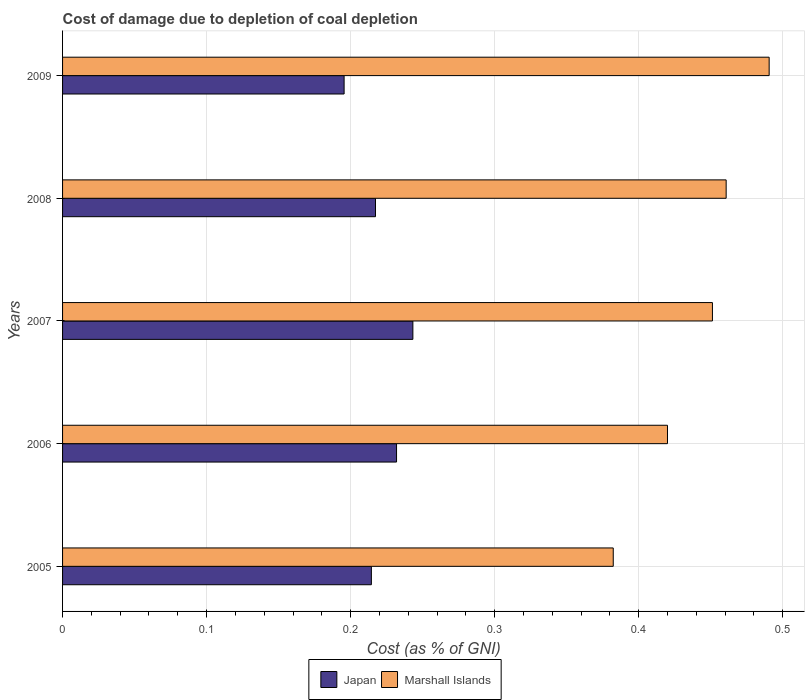How many different coloured bars are there?
Your response must be concise. 2. How many bars are there on the 2nd tick from the top?
Ensure brevity in your answer.  2. What is the label of the 2nd group of bars from the top?
Make the answer very short. 2008. In how many cases, is the number of bars for a given year not equal to the number of legend labels?
Keep it short and to the point. 0. What is the cost of damage caused due to coal depletion in Japan in 2009?
Your answer should be very brief. 0.2. Across all years, what is the maximum cost of damage caused due to coal depletion in Marshall Islands?
Ensure brevity in your answer.  0.49. Across all years, what is the minimum cost of damage caused due to coal depletion in Marshall Islands?
Give a very brief answer. 0.38. What is the total cost of damage caused due to coal depletion in Marshall Islands in the graph?
Offer a very short reply. 2.2. What is the difference between the cost of damage caused due to coal depletion in Marshall Islands in 2006 and that in 2009?
Provide a succinct answer. -0.07. What is the difference between the cost of damage caused due to coal depletion in Japan in 2009 and the cost of damage caused due to coal depletion in Marshall Islands in 2007?
Provide a short and direct response. -0.26. What is the average cost of damage caused due to coal depletion in Marshall Islands per year?
Offer a very short reply. 0.44. In the year 2005, what is the difference between the cost of damage caused due to coal depletion in Marshall Islands and cost of damage caused due to coal depletion in Japan?
Your answer should be compact. 0.17. In how many years, is the cost of damage caused due to coal depletion in Japan greater than 0.28 %?
Your response must be concise. 0. What is the ratio of the cost of damage caused due to coal depletion in Marshall Islands in 2005 to that in 2007?
Offer a very short reply. 0.85. Is the difference between the cost of damage caused due to coal depletion in Marshall Islands in 2006 and 2009 greater than the difference between the cost of damage caused due to coal depletion in Japan in 2006 and 2009?
Provide a succinct answer. No. What is the difference between the highest and the second highest cost of damage caused due to coal depletion in Japan?
Provide a succinct answer. 0.01. What is the difference between the highest and the lowest cost of damage caused due to coal depletion in Marshall Islands?
Keep it short and to the point. 0.11. In how many years, is the cost of damage caused due to coal depletion in Marshall Islands greater than the average cost of damage caused due to coal depletion in Marshall Islands taken over all years?
Offer a very short reply. 3. Is the sum of the cost of damage caused due to coal depletion in Marshall Islands in 2005 and 2007 greater than the maximum cost of damage caused due to coal depletion in Japan across all years?
Your answer should be very brief. Yes. What does the 1st bar from the top in 2007 represents?
Provide a short and direct response. Marshall Islands. How many bars are there?
Offer a very short reply. 10. Are all the bars in the graph horizontal?
Give a very brief answer. Yes. How many years are there in the graph?
Give a very brief answer. 5. Are the values on the major ticks of X-axis written in scientific E-notation?
Your response must be concise. No. Does the graph contain grids?
Give a very brief answer. Yes. Where does the legend appear in the graph?
Provide a succinct answer. Bottom center. What is the title of the graph?
Your answer should be very brief. Cost of damage due to depletion of coal depletion. What is the label or title of the X-axis?
Provide a short and direct response. Cost (as % of GNI). What is the label or title of the Y-axis?
Your response must be concise. Years. What is the Cost (as % of GNI) in Japan in 2005?
Keep it short and to the point. 0.21. What is the Cost (as % of GNI) in Marshall Islands in 2005?
Offer a very short reply. 0.38. What is the Cost (as % of GNI) in Japan in 2006?
Your answer should be very brief. 0.23. What is the Cost (as % of GNI) of Marshall Islands in 2006?
Your response must be concise. 0.42. What is the Cost (as % of GNI) of Japan in 2007?
Keep it short and to the point. 0.24. What is the Cost (as % of GNI) of Marshall Islands in 2007?
Provide a succinct answer. 0.45. What is the Cost (as % of GNI) in Japan in 2008?
Offer a very short reply. 0.22. What is the Cost (as % of GNI) of Marshall Islands in 2008?
Provide a succinct answer. 0.46. What is the Cost (as % of GNI) of Japan in 2009?
Offer a very short reply. 0.2. What is the Cost (as % of GNI) of Marshall Islands in 2009?
Provide a succinct answer. 0.49. Across all years, what is the maximum Cost (as % of GNI) in Japan?
Provide a short and direct response. 0.24. Across all years, what is the maximum Cost (as % of GNI) in Marshall Islands?
Your answer should be very brief. 0.49. Across all years, what is the minimum Cost (as % of GNI) in Japan?
Offer a very short reply. 0.2. Across all years, what is the minimum Cost (as % of GNI) in Marshall Islands?
Provide a succinct answer. 0.38. What is the total Cost (as % of GNI) of Japan in the graph?
Ensure brevity in your answer.  1.1. What is the total Cost (as % of GNI) of Marshall Islands in the graph?
Provide a succinct answer. 2.21. What is the difference between the Cost (as % of GNI) in Japan in 2005 and that in 2006?
Make the answer very short. -0.02. What is the difference between the Cost (as % of GNI) of Marshall Islands in 2005 and that in 2006?
Ensure brevity in your answer.  -0.04. What is the difference between the Cost (as % of GNI) of Japan in 2005 and that in 2007?
Ensure brevity in your answer.  -0.03. What is the difference between the Cost (as % of GNI) of Marshall Islands in 2005 and that in 2007?
Make the answer very short. -0.07. What is the difference between the Cost (as % of GNI) in Japan in 2005 and that in 2008?
Provide a succinct answer. -0. What is the difference between the Cost (as % of GNI) in Marshall Islands in 2005 and that in 2008?
Offer a very short reply. -0.08. What is the difference between the Cost (as % of GNI) in Japan in 2005 and that in 2009?
Provide a short and direct response. 0.02. What is the difference between the Cost (as % of GNI) of Marshall Islands in 2005 and that in 2009?
Your response must be concise. -0.11. What is the difference between the Cost (as % of GNI) of Japan in 2006 and that in 2007?
Offer a very short reply. -0.01. What is the difference between the Cost (as % of GNI) of Marshall Islands in 2006 and that in 2007?
Ensure brevity in your answer.  -0.03. What is the difference between the Cost (as % of GNI) of Japan in 2006 and that in 2008?
Keep it short and to the point. 0.01. What is the difference between the Cost (as % of GNI) in Marshall Islands in 2006 and that in 2008?
Give a very brief answer. -0.04. What is the difference between the Cost (as % of GNI) in Japan in 2006 and that in 2009?
Offer a very short reply. 0.04. What is the difference between the Cost (as % of GNI) of Marshall Islands in 2006 and that in 2009?
Ensure brevity in your answer.  -0.07. What is the difference between the Cost (as % of GNI) in Japan in 2007 and that in 2008?
Ensure brevity in your answer.  0.03. What is the difference between the Cost (as % of GNI) of Marshall Islands in 2007 and that in 2008?
Ensure brevity in your answer.  -0.01. What is the difference between the Cost (as % of GNI) in Japan in 2007 and that in 2009?
Offer a very short reply. 0.05. What is the difference between the Cost (as % of GNI) in Marshall Islands in 2007 and that in 2009?
Your answer should be compact. -0.04. What is the difference between the Cost (as % of GNI) of Japan in 2008 and that in 2009?
Give a very brief answer. 0.02. What is the difference between the Cost (as % of GNI) in Marshall Islands in 2008 and that in 2009?
Provide a short and direct response. -0.03. What is the difference between the Cost (as % of GNI) of Japan in 2005 and the Cost (as % of GNI) of Marshall Islands in 2006?
Your answer should be very brief. -0.21. What is the difference between the Cost (as % of GNI) of Japan in 2005 and the Cost (as % of GNI) of Marshall Islands in 2007?
Your response must be concise. -0.24. What is the difference between the Cost (as % of GNI) of Japan in 2005 and the Cost (as % of GNI) of Marshall Islands in 2008?
Your answer should be very brief. -0.25. What is the difference between the Cost (as % of GNI) of Japan in 2005 and the Cost (as % of GNI) of Marshall Islands in 2009?
Give a very brief answer. -0.28. What is the difference between the Cost (as % of GNI) in Japan in 2006 and the Cost (as % of GNI) in Marshall Islands in 2007?
Provide a succinct answer. -0.22. What is the difference between the Cost (as % of GNI) in Japan in 2006 and the Cost (as % of GNI) in Marshall Islands in 2008?
Offer a terse response. -0.23. What is the difference between the Cost (as % of GNI) of Japan in 2006 and the Cost (as % of GNI) of Marshall Islands in 2009?
Provide a short and direct response. -0.26. What is the difference between the Cost (as % of GNI) in Japan in 2007 and the Cost (as % of GNI) in Marshall Islands in 2008?
Offer a terse response. -0.22. What is the difference between the Cost (as % of GNI) of Japan in 2007 and the Cost (as % of GNI) of Marshall Islands in 2009?
Keep it short and to the point. -0.25. What is the difference between the Cost (as % of GNI) of Japan in 2008 and the Cost (as % of GNI) of Marshall Islands in 2009?
Offer a very short reply. -0.27. What is the average Cost (as % of GNI) of Japan per year?
Provide a succinct answer. 0.22. What is the average Cost (as % of GNI) of Marshall Islands per year?
Your answer should be very brief. 0.44. In the year 2005, what is the difference between the Cost (as % of GNI) in Japan and Cost (as % of GNI) in Marshall Islands?
Offer a terse response. -0.17. In the year 2006, what is the difference between the Cost (as % of GNI) of Japan and Cost (as % of GNI) of Marshall Islands?
Make the answer very short. -0.19. In the year 2007, what is the difference between the Cost (as % of GNI) in Japan and Cost (as % of GNI) in Marshall Islands?
Keep it short and to the point. -0.21. In the year 2008, what is the difference between the Cost (as % of GNI) in Japan and Cost (as % of GNI) in Marshall Islands?
Provide a short and direct response. -0.24. In the year 2009, what is the difference between the Cost (as % of GNI) in Japan and Cost (as % of GNI) in Marshall Islands?
Keep it short and to the point. -0.3. What is the ratio of the Cost (as % of GNI) of Japan in 2005 to that in 2006?
Your response must be concise. 0.92. What is the ratio of the Cost (as % of GNI) of Marshall Islands in 2005 to that in 2006?
Provide a succinct answer. 0.91. What is the ratio of the Cost (as % of GNI) of Japan in 2005 to that in 2007?
Offer a very short reply. 0.88. What is the ratio of the Cost (as % of GNI) of Marshall Islands in 2005 to that in 2007?
Provide a short and direct response. 0.85. What is the ratio of the Cost (as % of GNI) in Marshall Islands in 2005 to that in 2008?
Make the answer very short. 0.83. What is the ratio of the Cost (as % of GNI) of Japan in 2005 to that in 2009?
Make the answer very short. 1.1. What is the ratio of the Cost (as % of GNI) in Marshall Islands in 2005 to that in 2009?
Offer a terse response. 0.78. What is the ratio of the Cost (as % of GNI) in Japan in 2006 to that in 2007?
Your answer should be very brief. 0.95. What is the ratio of the Cost (as % of GNI) in Marshall Islands in 2006 to that in 2007?
Provide a short and direct response. 0.93. What is the ratio of the Cost (as % of GNI) in Japan in 2006 to that in 2008?
Provide a succinct answer. 1.07. What is the ratio of the Cost (as % of GNI) in Marshall Islands in 2006 to that in 2008?
Ensure brevity in your answer.  0.91. What is the ratio of the Cost (as % of GNI) in Japan in 2006 to that in 2009?
Keep it short and to the point. 1.19. What is the ratio of the Cost (as % of GNI) in Marshall Islands in 2006 to that in 2009?
Offer a very short reply. 0.86. What is the ratio of the Cost (as % of GNI) of Japan in 2007 to that in 2008?
Give a very brief answer. 1.12. What is the ratio of the Cost (as % of GNI) of Marshall Islands in 2007 to that in 2008?
Provide a short and direct response. 0.98. What is the ratio of the Cost (as % of GNI) in Japan in 2007 to that in 2009?
Keep it short and to the point. 1.24. What is the ratio of the Cost (as % of GNI) in Marshall Islands in 2007 to that in 2009?
Provide a succinct answer. 0.92. What is the ratio of the Cost (as % of GNI) of Japan in 2008 to that in 2009?
Offer a very short reply. 1.11. What is the ratio of the Cost (as % of GNI) in Marshall Islands in 2008 to that in 2009?
Keep it short and to the point. 0.94. What is the difference between the highest and the second highest Cost (as % of GNI) of Japan?
Your answer should be compact. 0.01. What is the difference between the highest and the second highest Cost (as % of GNI) in Marshall Islands?
Your answer should be very brief. 0.03. What is the difference between the highest and the lowest Cost (as % of GNI) of Japan?
Your response must be concise. 0.05. What is the difference between the highest and the lowest Cost (as % of GNI) of Marshall Islands?
Your answer should be very brief. 0.11. 